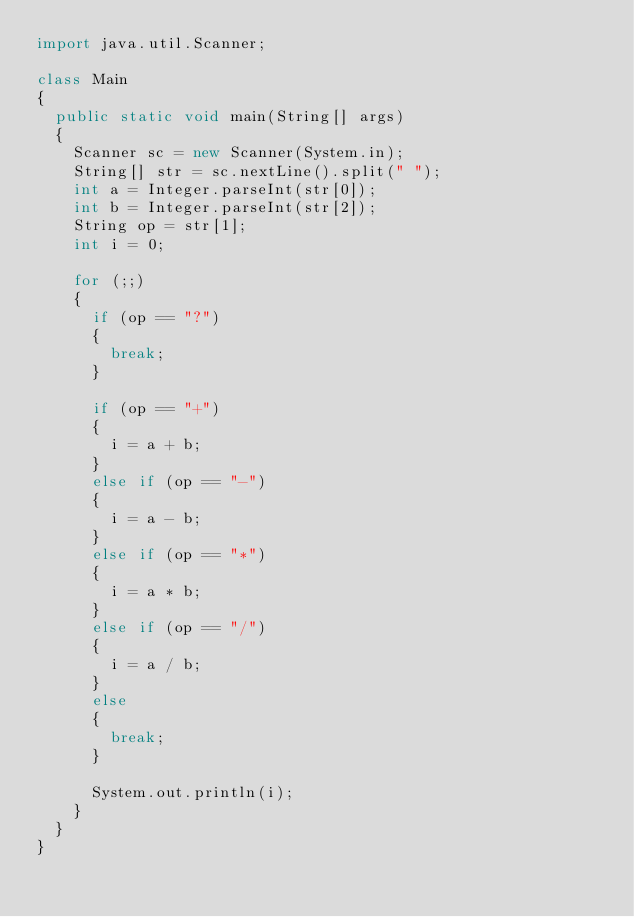Convert code to text. <code><loc_0><loc_0><loc_500><loc_500><_Java_>import java.util.Scanner;

class Main
{
	public static void main(String[] args)
	{
		Scanner sc = new Scanner(System.in);
		String[] str = sc.nextLine().split(" ");
		int a = Integer.parseInt(str[0]);
		int b = Integer.parseInt(str[2]);
		String op = str[1];
		int i = 0;
		
		for (;;)
		{
			if (op == "?")
			{
				break;
			}
			
			if (op == "+")
			{
				i = a + b;
			}
			else if (op == "-")
			{
				i = a - b;
			}
			else if (op == "*")
			{
				i = a * b;
			}
			else if (op == "/")
			{
				i = a / b;
			}
			else
			{
				break;
			}
			
			System.out.println(i);
		}
	}
}</code> 